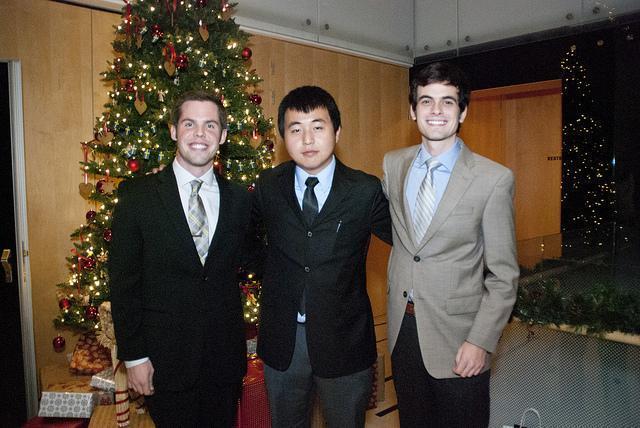How many Christmas trees are in the background?
Give a very brief answer. 2. How many men are wearing Khaki pants?
Give a very brief answer. 0. How many boys?
Give a very brief answer. 3. How many women are in the picture?
Give a very brief answer. 0. How many of these people are male?
Give a very brief answer. 3. How many people are in the photo?
Give a very brief answer. 3. How many men are in this photo?
Give a very brief answer. 3. How many men are in this picture?
Give a very brief answer. 3. How many people are there?
Give a very brief answer. 3. 